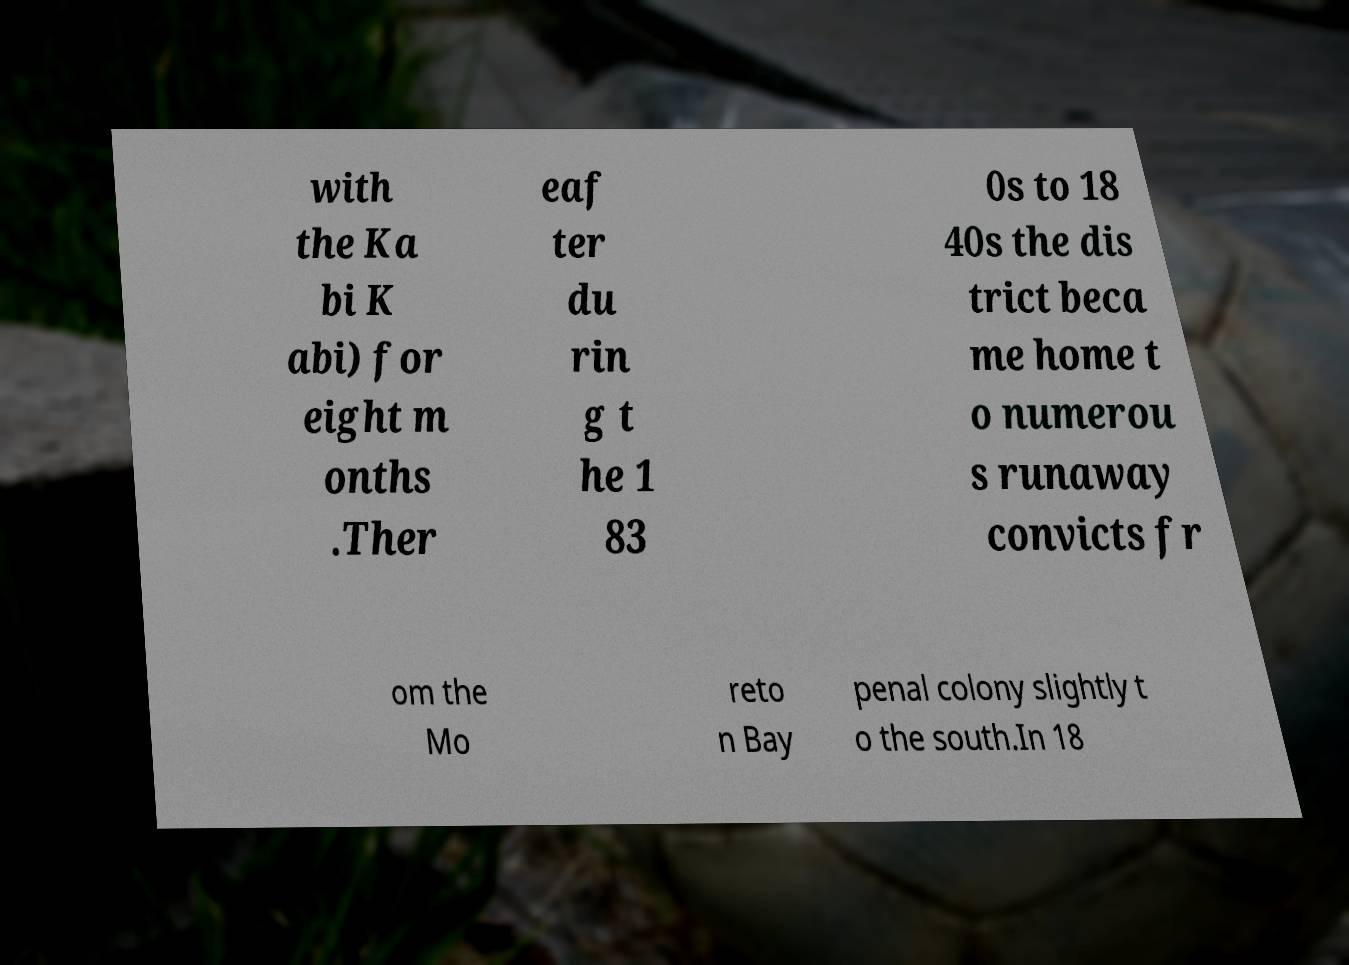Could you extract and type out the text from this image? with the Ka bi K abi) for eight m onths .Ther eaf ter du rin g t he 1 83 0s to 18 40s the dis trict beca me home t o numerou s runaway convicts fr om the Mo reto n Bay penal colony slightly t o the south.In 18 